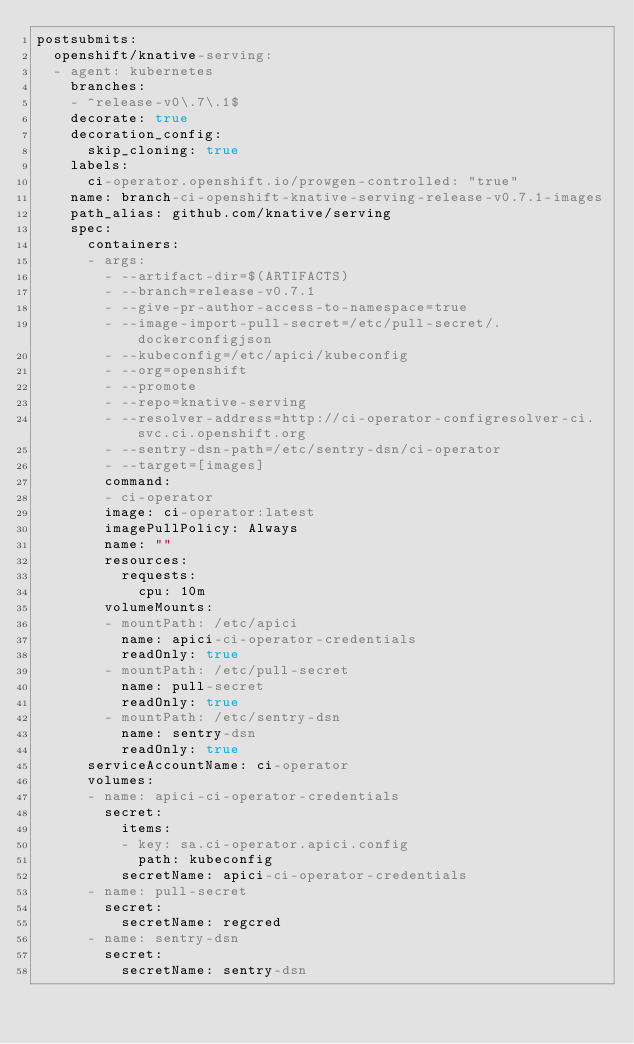Convert code to text. <code><loc_0><loc_0><loc_500><loc_500><_YAML_>postsubmits:
  openshift/knative-serving:
  - agent: kubernetes
    branches:
    - ^release-v0\.7\.1$
    decorate: true
    decoration_config:
      skip_cloning: true
    labels:
      ci-operator.openshift.io/prowgen-controlled: "true"
    name: branch-ci-openshift-knative-serving-release-v0.7.1-images
    path_alias: github.com/knative/serving
    spec:
      containers:
      - args:
        - --artifact-dir=$(ARTIFACTS)
        - --branch=release-v0.7.1
        - --give-pr-author-access-to-namespace=true
        - --image-import-pull-secret=/etc/pull-secret/.dockerconfigjson
        - --kubeconfig=/etc/apici/kubeconfig
        - --org=openshift
        - --promote
        - --repo=knative-serving
        - --resolver-address=http://ci-operator-configresolver-ci.svc.ci.openshift.org
        - --sentry-dsn-path=/etc/sentry-dsn/ci-operator
        - --target=[images]
        command:
        - ci-operator
        image: ci-operator:latest
        imagePullPolicy: Always
        name: ""
        resources:
          requests:
            cpu: 10m
        volumeMounts:
        - mountPath: /etc/apici
          name: apici-ci-operator-credentials
          readOnly: true
        - mountPath: /etc/pull-secret
          name: pull-secret
          readOnly: true
        - mountPath: /etc/sentry-dsn
          name: sentry-dsn
          readOnly: true
      serviceAccountName: ci-operator
      volumes:
      - name: apici-ci-operator-credentials
        secret:
          items:
          - key: sa.ci-operator.apici.config
            path: kubeconfig
          secretName: apici-ci-operator-credentials
      - name: pull-secret
        secret:
          secretName: regcred
      - name: sentry-dsn
        secret:
          secretName: sentry-dsn
</code> 